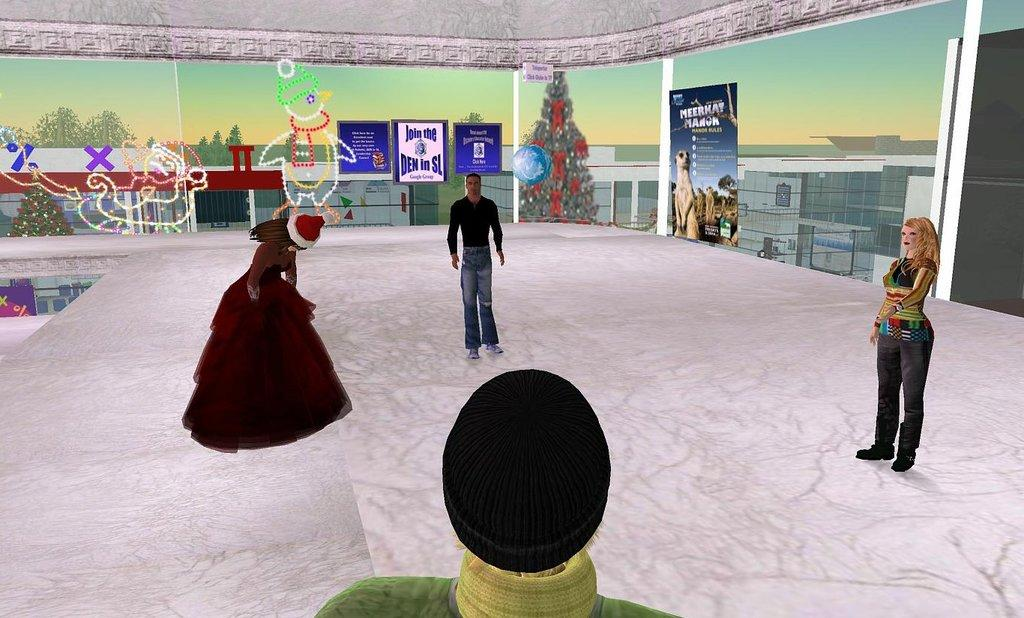How many people are in the image? There are people in the image, but the exact number is not specified. What is the position of the people in the image? The people are on the floor in the image. What type of objects can be seen in the image? There are decorative objects and boards visible in the image. What type of structures are in the image? There are buildings in the image. What type of vegetation is in the image? There are trees in the image. What part of the natural environment is visible in the image? The sky is visible in the image. Is there a plantation visible in the image? There is no mention of a plantation in the provided facts, so it cannot be determined if one is present in the image. Is the image covered in snow? The facts do not mention snow, so it cannot be determined if the image is covered in snow. 